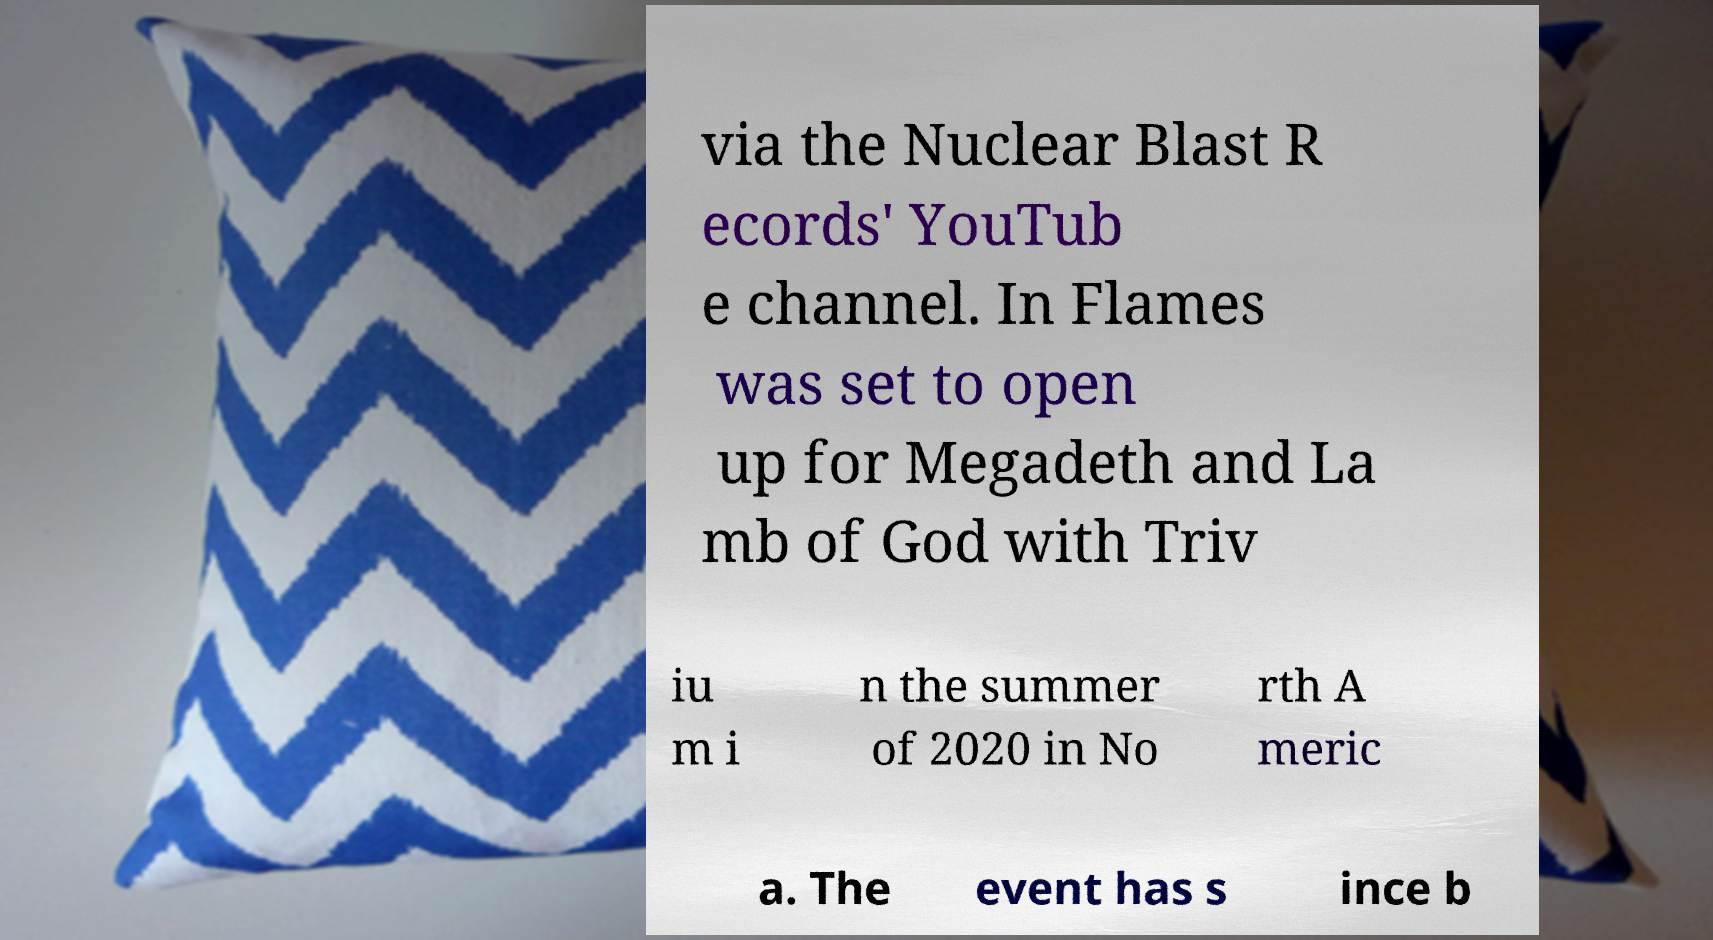There's text embedded in this image that I need extracted. Can you transcribe it verbatim? via the Nuclear Blast R ecords' YouTub e channel. In Flames was set to open up for Megadeth and La mb of God with Triv iu m i n the summer of 2020 in No rth A meric a. The event has s ince b 